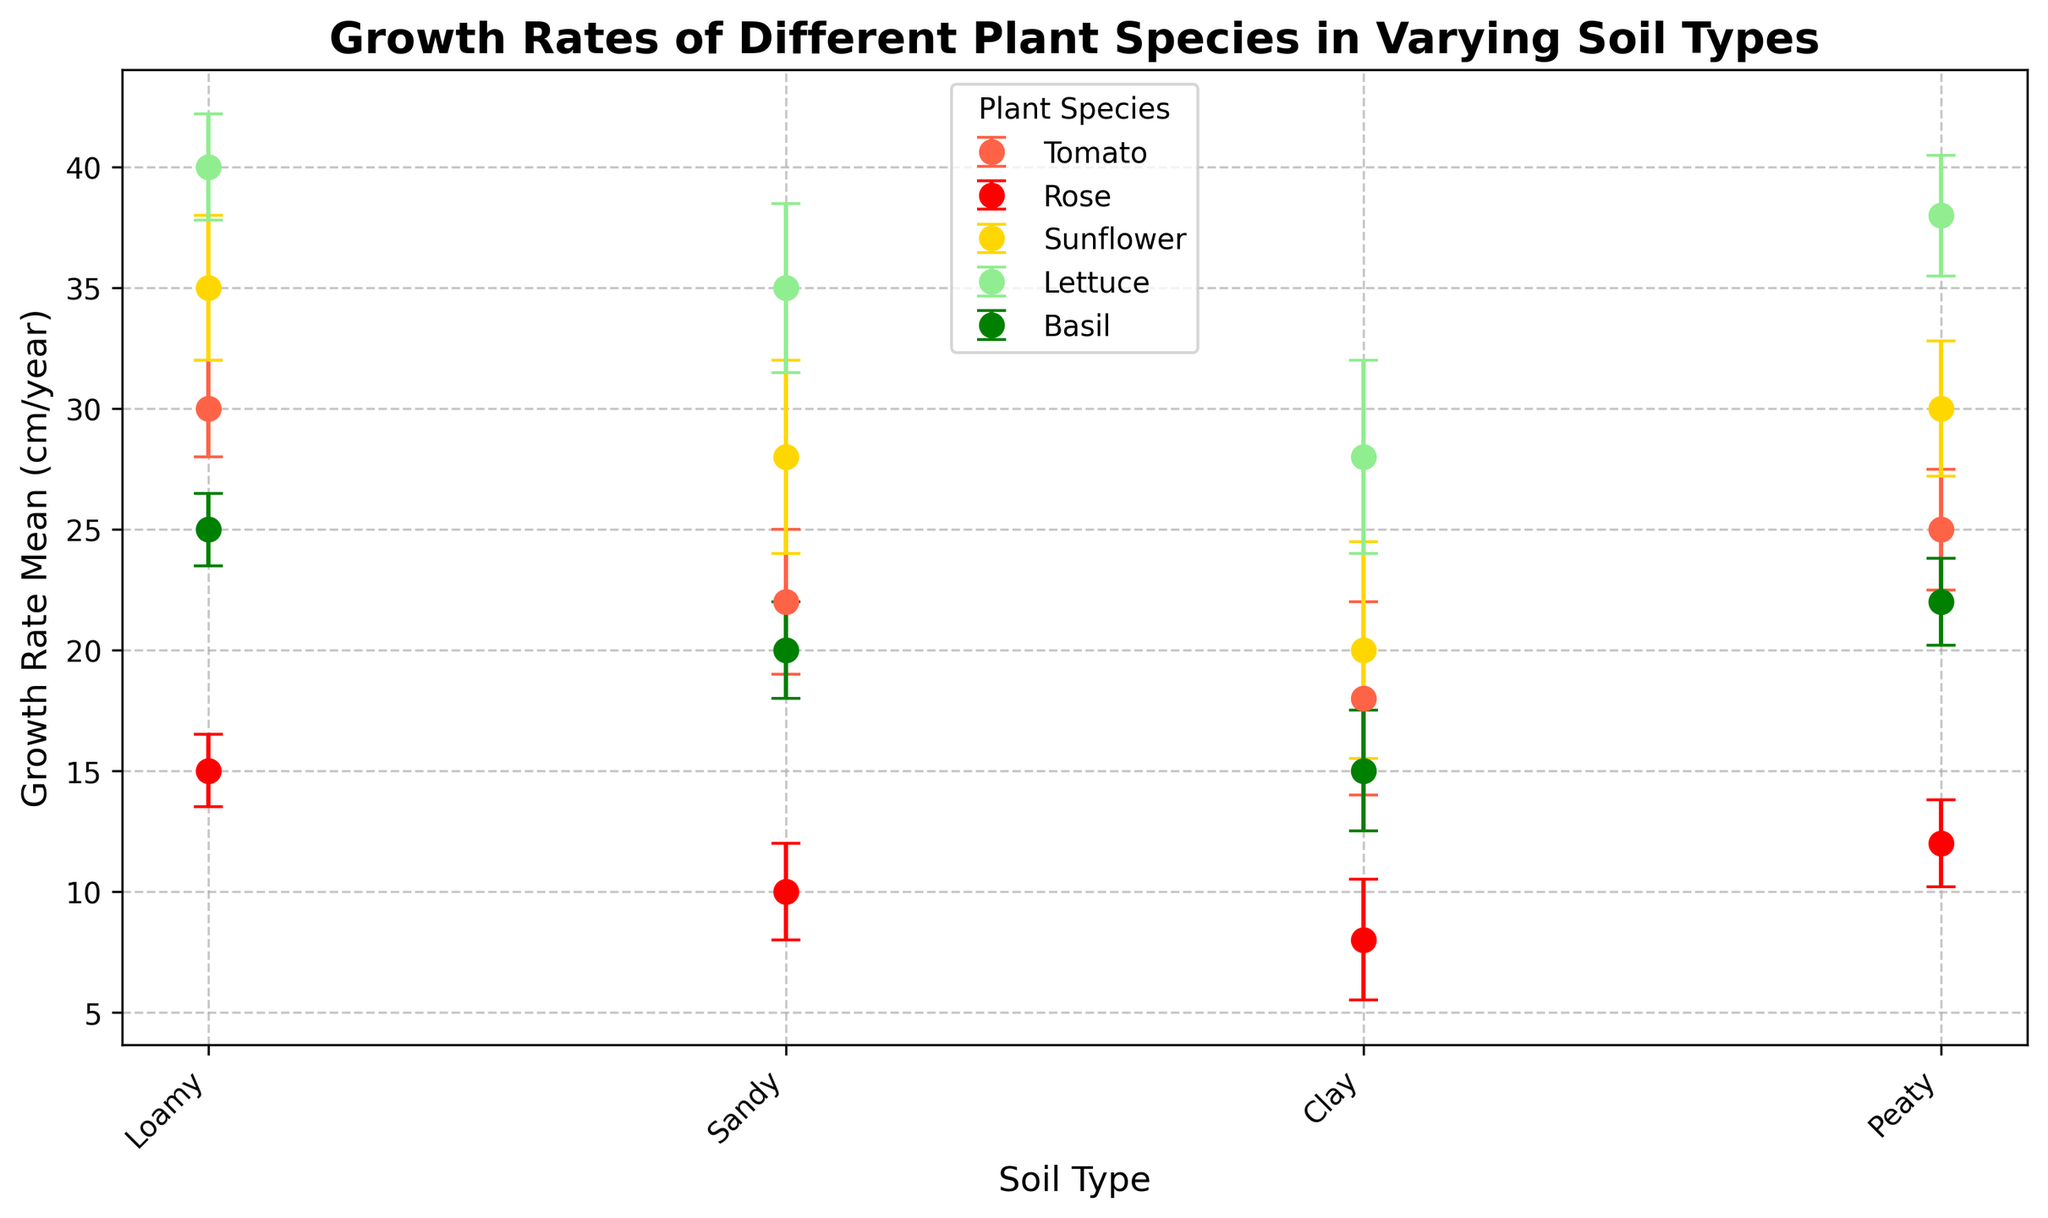Which plant species has the highest mean growth rate in Loamy soil? In the plot, look at the markers for each plant species in the Loamy soil category and compare their mean growth rates. The highest mean growth rate is for the plant species has the tallest marker.
Answer: Lettuce What is the difference in mean growth rate between Tomato and Sunflower in Sandy soil? First, find the mean growth rates of Tomato and Sunflower in Sandy soil by looking at the heights of their respective markers. Then, compute the difference by subtracting the smaller mean from the larger mean.
Answer: 6 cm/year Which plant species shows the most consistent growth rate across all soil types, as indicated by the smallest error bars? Check the error bars for each plant species across all soil types. Consistent growth rate is indicated by the smallest error bars. Compare the size of the error bars to determine which species has the smallest.
Answer: Basil In which soil type do Roses have the smallest mean growth rate? Look at the markers representing Roses in each of the soil types and identify the soil type with the shortest marker, indicating the smallest mean growth rate.
Answer: Clay How does the mean growth rate of Lettuce in Clay soil compare to that of Sunflower in Loamy soil? Identify the mean growth rate of Lettuce in Clay soil and Sunflower in Loamy soil by looking at the respective marker heights. Compare the two values to determine which is higher.
Answer: Lettuce in Clay soil has a lower mean growth rate than Sunflower in Loamy soil Rank the soil types for Tomato based on their mean growth rates from highest to lowest. Look at the markers for Tomato in all soil types and order them based on the height of the markers (mean growth rates) from the highest to the lowest.
Answer: Loamy, Peaty, Sandy, Clay Which plant species has the greatest variability in growth rate in Sandy soil? Examine the error bars for each plant species in Sandy soil and identify the species with the largest error bar, indicating the greatest variability.
Answer: Sunflower What is the average growth rate of Basil across all soil types showing in the figure? Find the mean growth rates of Basil in all soil types, sum them up, and then divide by the number of soil types to get the average. Calculation: (25 + 20 + 15 + 22) / 4
Answer: 20.5 cm/year Considering the variability, which soil type shows the most variability in growth rate across all plant species? Look at the length of error bars for all plant species within each soil type. The soil type with the longest or most frequent large error bars indicates the highest variability.
Answer: Sandy 